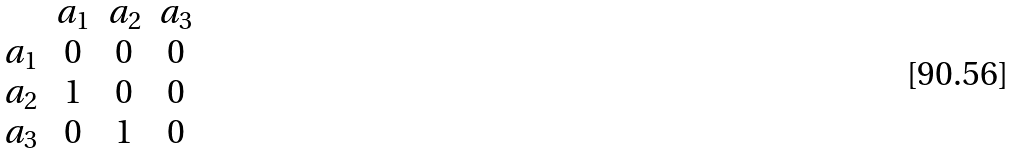<formula> <loc_0><loc_0><loc_500><loc_500>\begin{array} { c c c c } & a _ { 1 } & a _ { 2 } & a _ { 3 } \\ a _ { 1 } & 0 & 0 & 0 \\ a _ { 2 } & 1 & 0 & 0 \\ a _ { 3 } & 0 & 1 & 0 \end{array}</formula> 